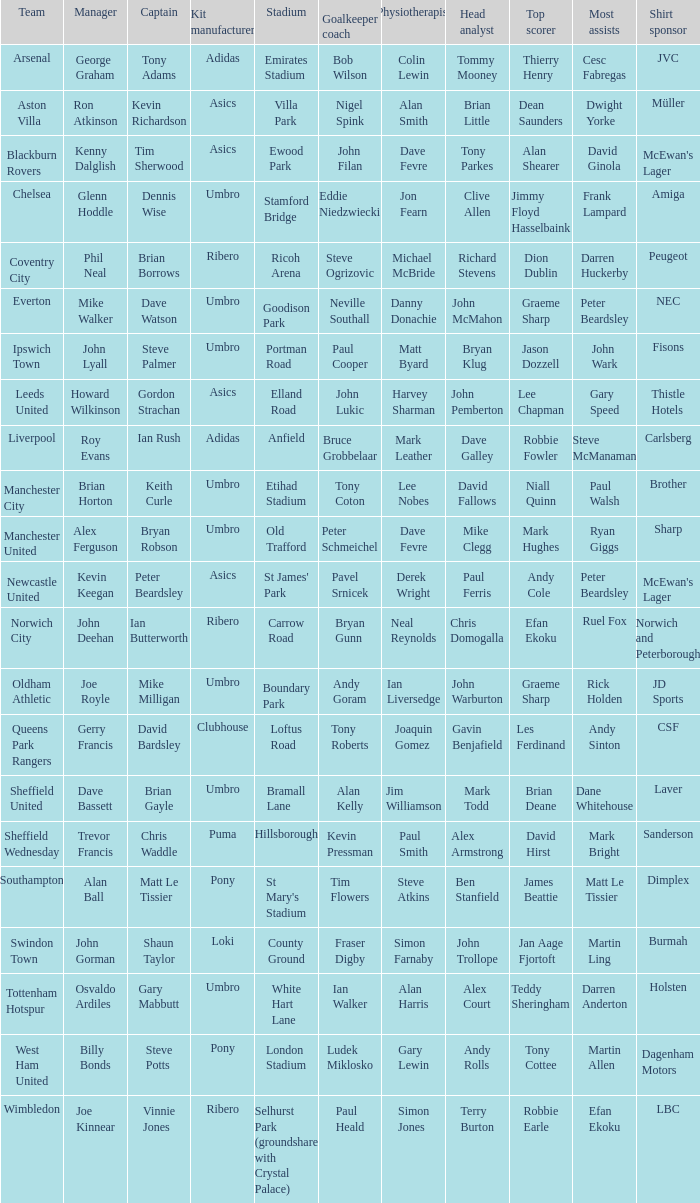What is the kit manufacturer that has billy bonds as the manager? Pony. 